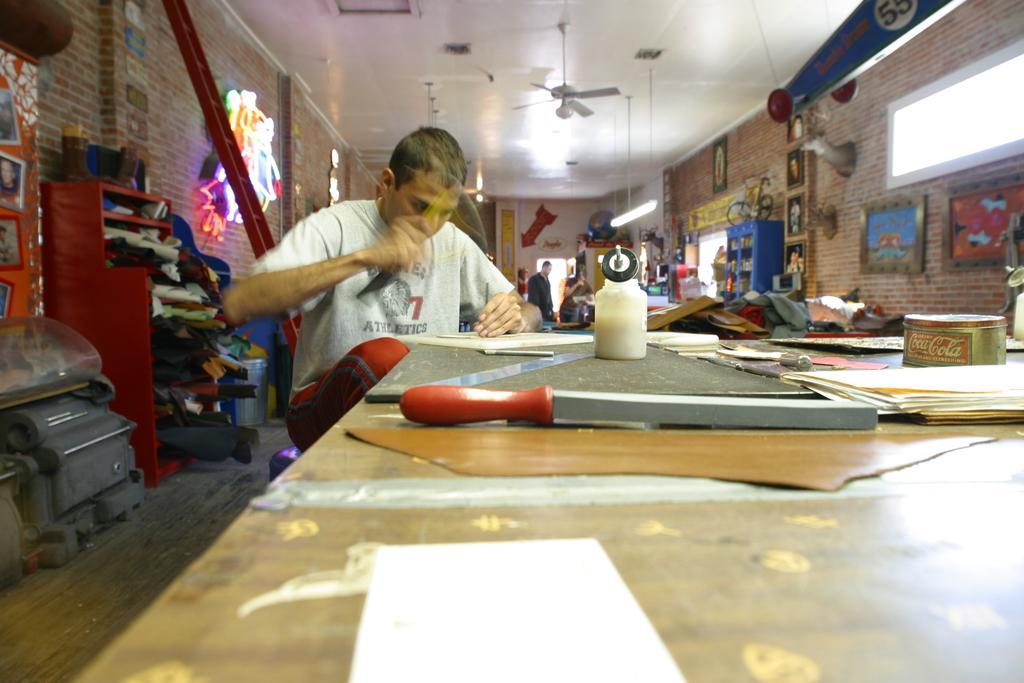Please provide a concise description of this image. In this image i can see a person visible in front of the table , I can see a knife, papers and bottles kept on it. at the top I can see a fan hanging through roof and I can see window and I can see photo frames attached to the wall, on the right side , on the left side I can see a cupboard ,on the cupboard I can see the clothes and I can see the wall. 